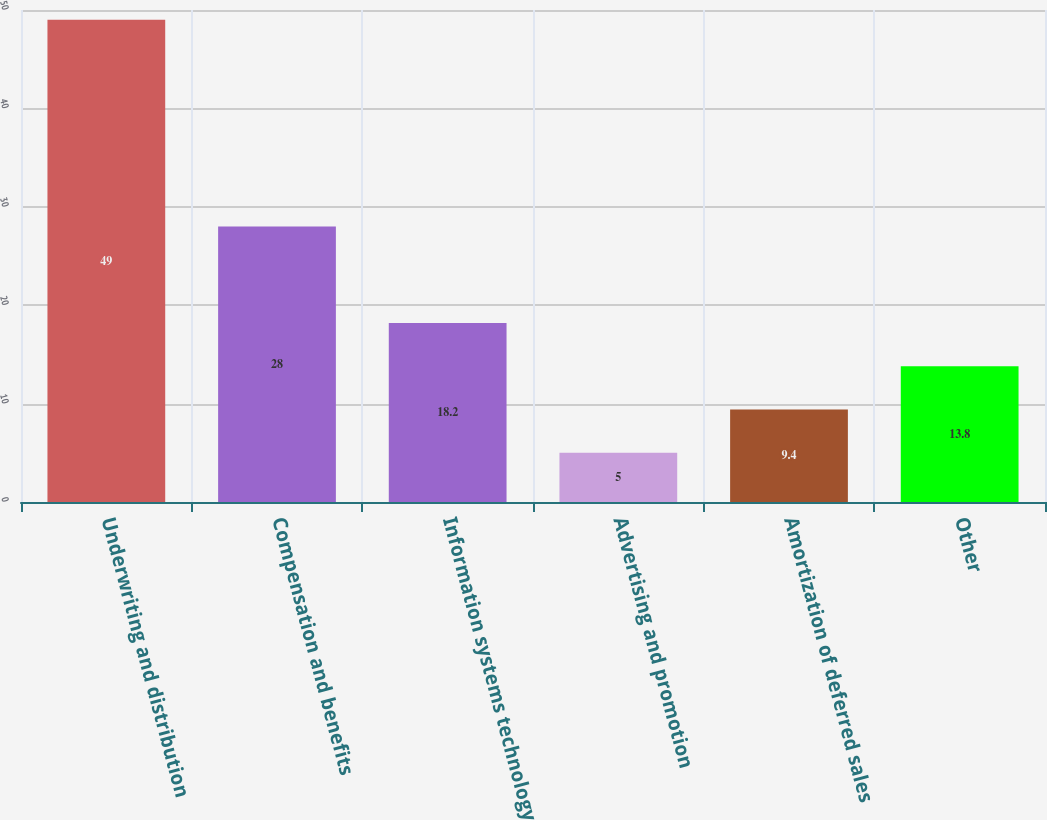Convert chart to OTSL. <chart><loc_0><loc_0><loc_500><loc_500><bar_chart><fcel>Underwriting and distribution<fcel>Compensation and benefits<fcel>Information systems technology<fcel>Advertising and promotion<fcel>Amortization of deferred sales<fcel>Other<nl><fcel>49<fcel>28<fcel>18.2<fcel>5<fcel>9.4<fcel>13.8<nl></chart> 